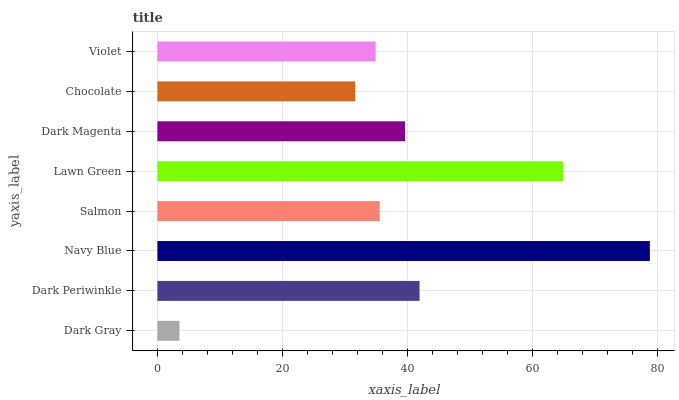Is Dark Gray the minimum?
Answer yes or no. Yes. Is Navy Blue the maximum?
Answer yes or no. Yes. Is Dark Periwinkle the minimum?
Answer yes or no. No. Is Dark Periwinkle the maximum?
Answer yes or no. No. Is Dark Periwinkle greater than Dark Gray?
Answer yes or no. Yes. Is Dark Gray less than Dark Periwinkle?
Answer yes or no. Yes. Is Dark Gray greater than Dark Periwinkle?
Answer yes or no. No. Is Dark Periwinkle less than Dark Gray?
Answer yes or no. No. Is Dark Magenta the high median?
Answer yes or no. Yes. Is Salmon the low median?
Answer yes or no. Yes. Is Dark Periwinkle the high median?
Answer yes or no. No. Is Violet the low median?
Answer yes or no. No. 